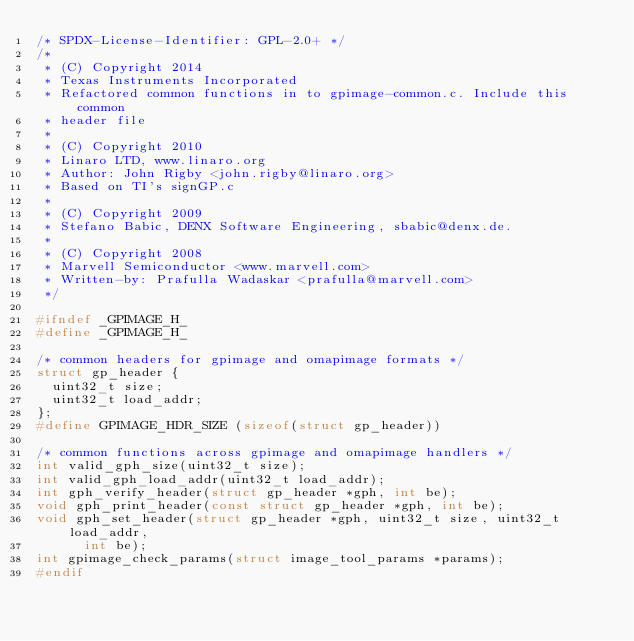Convert code to text. <code><loc_0><loc_0><loc_500><loc_500><_C_>/* SPDX-License-Identifier: GPL-2.0+ */
/*
 * (C) Copyright 2014
 * Texas Instruments Incorporated
 * Refactored common functions in to gpimage-common.c. Include this common
 * header file
 *
 * (C) Copyright 2010
 * Linaro LTD, www.linaro.org
 * Author: John Rigby <john.rigby@linaro.org>
 * Based on TI's signGP.c
 *
 * (C) Copyright 2009
 * Stefano Babic, DENX Software Engineering, sbabic@denx.de.
 *
 * (C) Copyright 2008
 * Marvell Semiconductor <www.marvell.com>
 * Written-by: Prafulla Wadaskar <prafulla@marvell.com>
 */

#ifndef _GPIMAGE_H_
#define _GPIMAGE_H_

/* common headers for gpimage and omapimage formats */
struct gp_header {
	uint32_t size;
	uint32_t load_addr;
};
#define GPIMAGE_HDR_SIZE (sizeof(struct gp_header))

/* common functions across gpimage and omapimage handlers */
int valid_gph_size(uint32_t size);
int valid_gph_load_addr(uint32_t load_addr);
int gph_verify_header(struct gp_header *gph, int be);
void gph_print_header(const struct gp_header *gph, int be);
void gph_set_header(struct gp_header *gph, uint32_t size, uint32_t load_addr,
			int be);
int gpimage_check_params(struct image_tool_params *params);
#endif
</code> 